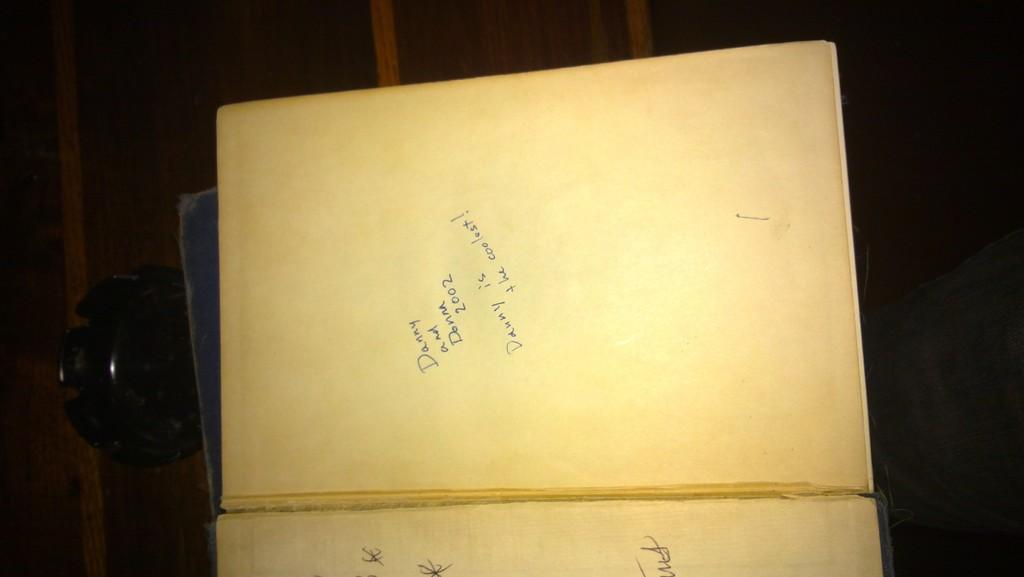<image>
Share a concise interpretation of the image provided. A yellowed page has Danny and Donna scrawled next to the year 2002. 